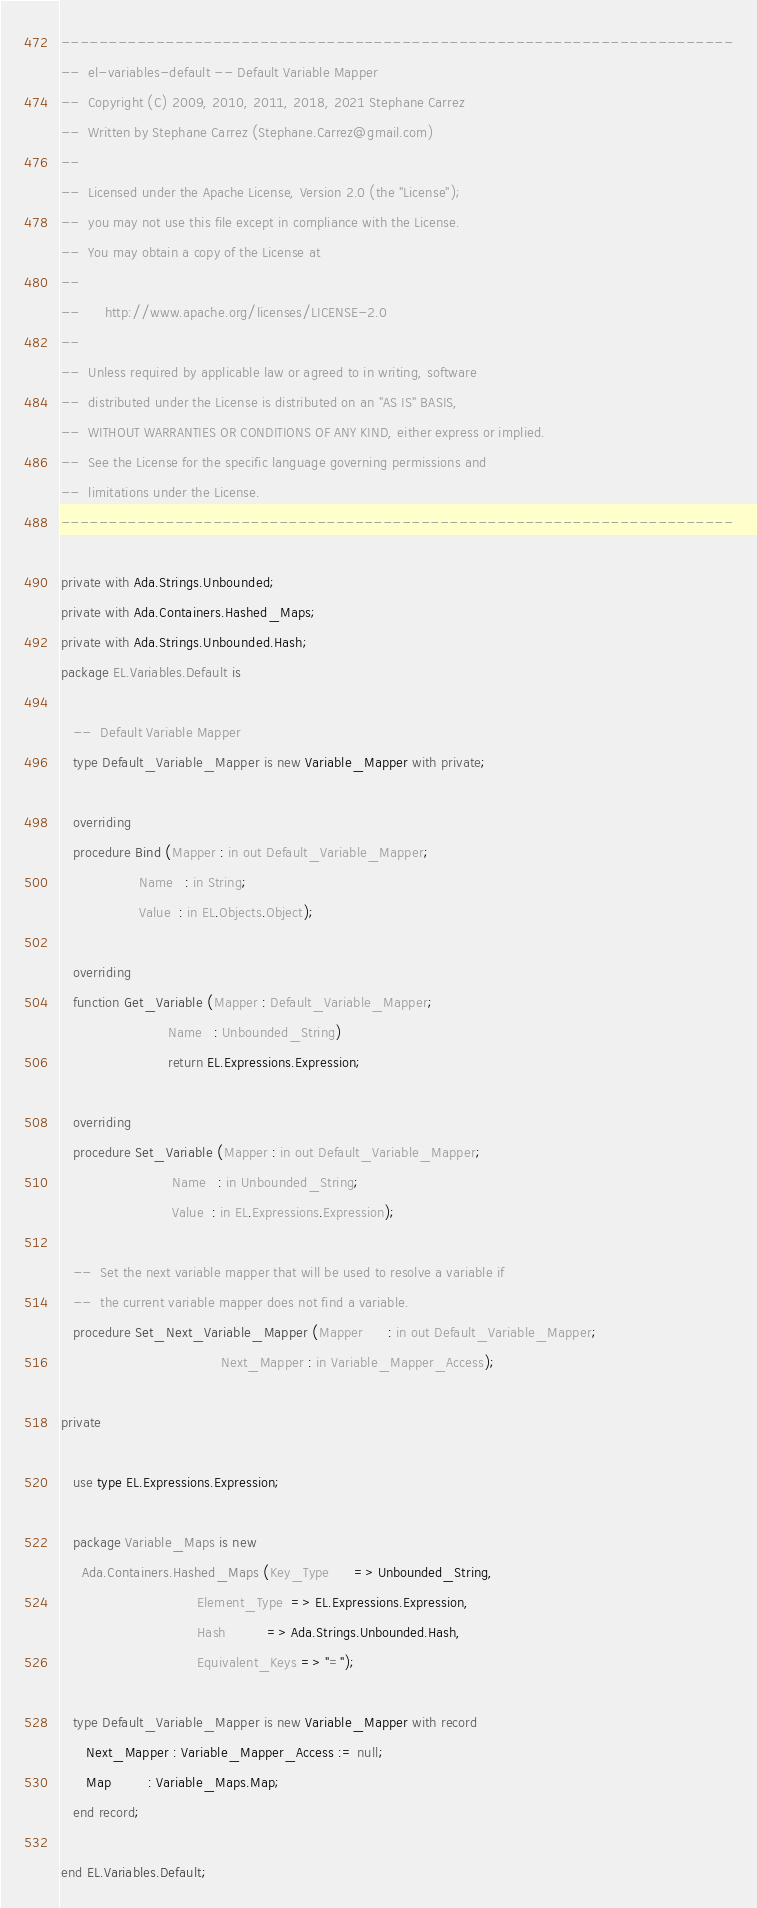<code> <loc_0><loc_0><loc_500><loc_500><_Ada_>-----------------------------------------------------------------------
--  el-variables-default -- Default Variable Mapper
--  Copyright (C) 2009, 2010, 2011, 2018, 2021 Stephane Carrez
--  Written by Stephane Carrez (Stephane.Carrez@gmail.com)
--
--  Licensed under the Apache License, Version 2.0 (the "License");
--  you may not use this file except in compliance with the License.
--  You may obtain a copy of the License at
--
--      http://www.apache.org/licenses/LICENSE-2.0
--
--  Unless required by applicable law or agreed to in writing, software
--  distributed under the License is distributed on an "AS IS" BASIS,
--  WITHOUT WARRANTIES OR CONDITIONS OF ANY KIND, either express or implied.
--  See the License for the specific language governing permissions and
--  limitations under the License.
-----------------------------------------------------------------------

private with Ada.Strings.Unbounded;
private with Ada.Containers.Hashed_Maps;
private with Ada.Strings.Unbounded.Hash;
package EL.Variables.Default is

   --  Default Variable Mapper
   type Default_Variable_Mapper is new Variable_Mapper with private;

   overriding
   procedure Bind (Mapper : in out Default_Variable_Mapper;
                   Name   : in String;
                   Value  : in EL.Objects.Object);

   overriding
   function Get_Variable (Mapper : Default_Variable_Mapper;
                          Name   : Unbounded_String)
                          return EL.Expressions.Expression;

   overriding
   procedure Set_Variable (Mapper : in out Default_Variable_Mapper;
                           Name   : in Unbounded_String;
                           Value  : in EL.Expressions.Expression);

   --  Set the next variable mapper that will be used to resolve a variable if
   --  the current variable mapper does not find a variable.
   procedure Set_Next_Variable_Mapper (Mapper      : in out Default_Variable_Mapper;
                                       Next_Mapper : in Variable_Mapper_Access);

private

   use type EL.Expressions.Expression;

   package Variable_Maps is new
     Ada.Containers.Hashed_Maps (Key_Type      => Unbounded_String,
                                 Element_Type  => EL.Expressions.Expression,
                                 Hash          => Ada.Strings.Unbounded.Hash,
                                 Equivalent_Keys => "=");

   type Default_Variable_Mapper is new Variable_Mapper with record
      Next_Mapper : Variable_Mapper_Access := null;
      Map         : Variable_Maps.Map;
   end record;

end EL.Variables.Default;
</code> 